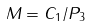Convert formula to latex. <formula><loc_0><loc_0><loc_500><loc_500>M = C _ { 1 } / P _ { 3 }</formula> 